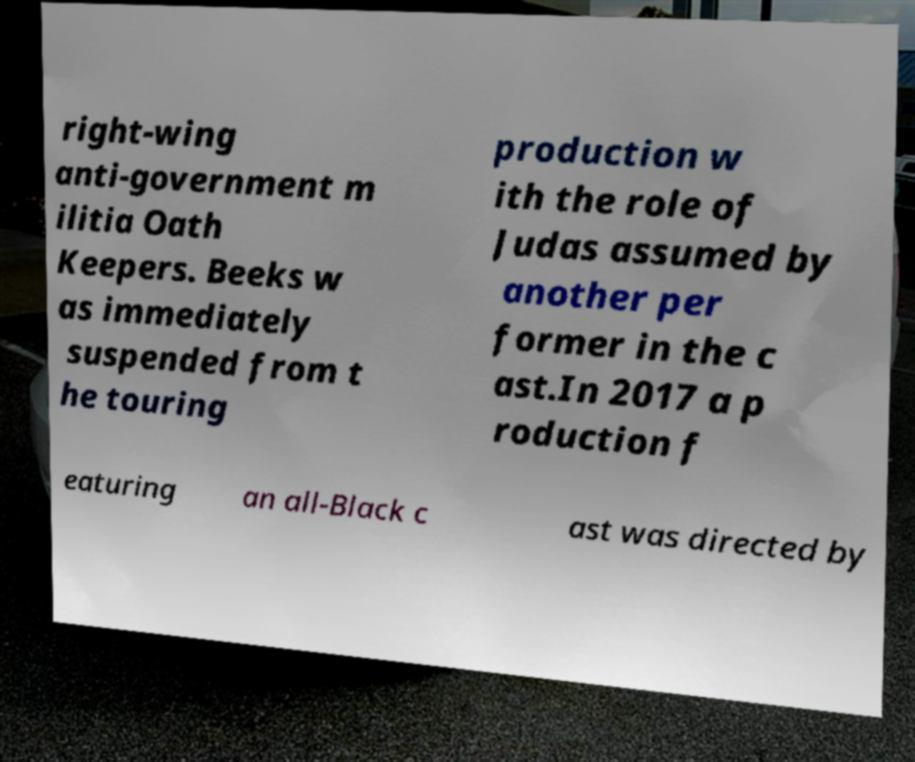Could you extract and type out the text from this image? right-wing anti-government m ilitia Oath Keepers. Beeks w as immediately suspended from t he touring production w ith the role of Judas assumed by another per former in the c ast.In 2017 a p roduction f eaturing an all-Black c ast was directed by 